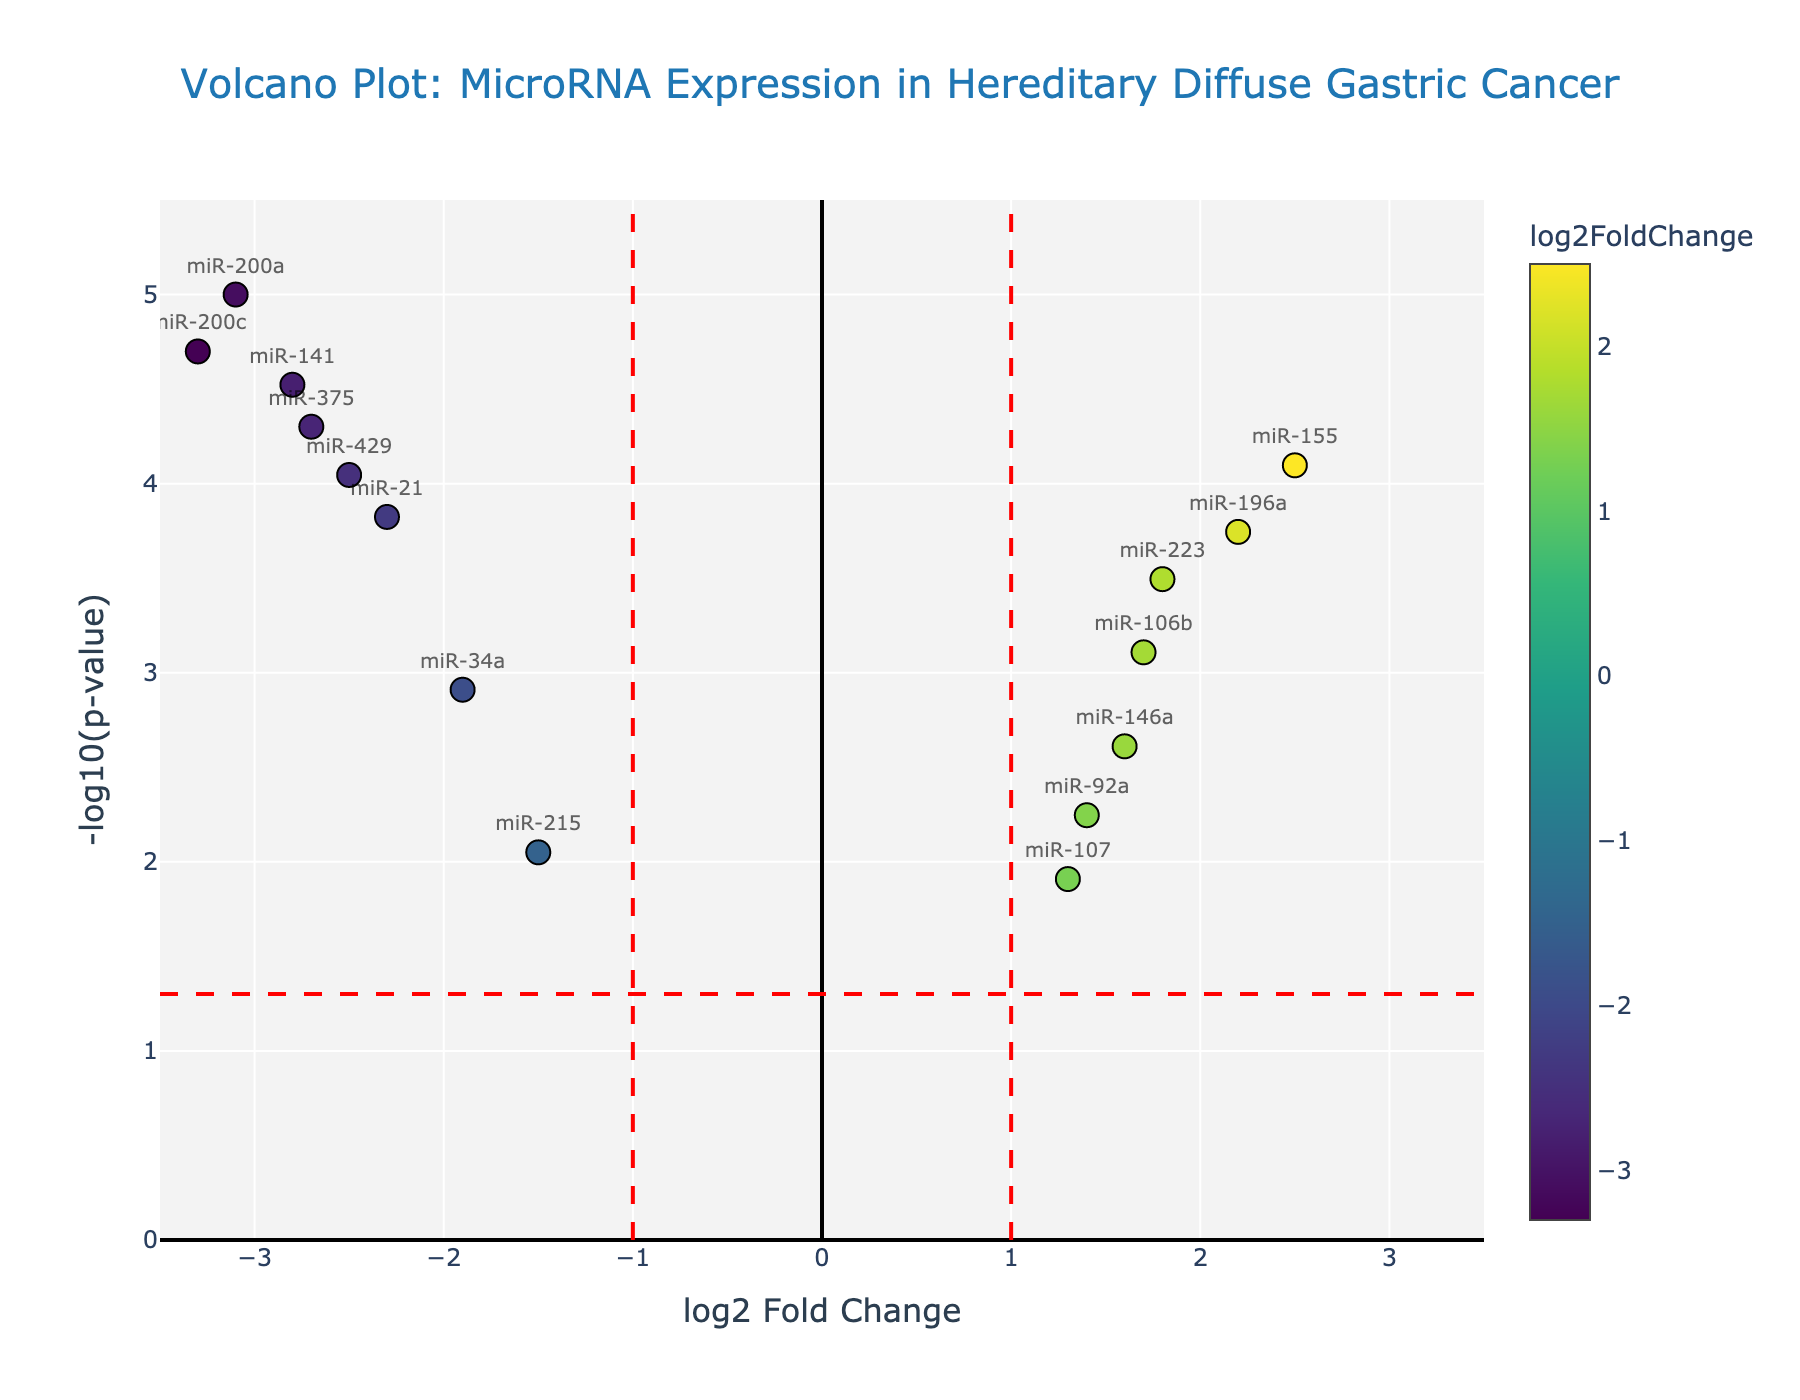How many miRNAs have a log2 fold change greater than 1? To find this, count the data points on the x-axis that are to the right of the log2 fold change of 1. Each point represents a miRNA with its log2 fold change value.
Answer: 5 Which miRNAs show the strongest upregulation? Look for the miRNAs that have the highest log2 fold change values (positive values) and lowest p-values (higher on the y-axis).
Answer: miR-155 and miR-196a What is the significance level represented by the horizontal red dashed line? The horizontal red line indicates the threshold for statistical significance, typically -log10(0.05). The y-coordinate of this line represents this value.
Answer: 1.3 How many miRNAs are significantly upregulated and have a log2 fold change greater than 2? Identify the data points above the horizontal red dashed line and to the right of the vertical red dashed line at 2.
Answer: 2 Which miRNA has the lowest p-value? The miRNA farthest up on the y-axis represents the lowest p-value.
Answer: miR-200a How many miRNAs are significantly downregulated with a log2 fold change less than -2? Count the data points above the horizontal red dashed line and to the left of the vertical red dashed line at -2.
Answer: 5 What does a positive log2 fold change signify in this plot? A positive log2 fold change indicates that the miRNA is upregulated in hereditary diffuse gastric cancer patients compared to the controls.
Answer: Upregulation What does a high -log10(p-value) indicate in terms of statistical significance? A higher -log10(p-value) means the p-value is smaller, hence the result is more statistically significant.
Answer: Higher statistical significance Which miRNA has the highest -log10(p-value) but a negative log2 fold change? Look for the miRNA with the highest y-axis value in the left half of the plot.
Answer: miR-200c How many miRNAs are not considered significant based on the p-value threshold shown? Count the miRNAs below the horizontal red dashed line, which represents the p-value threshold.
Answer: 4 